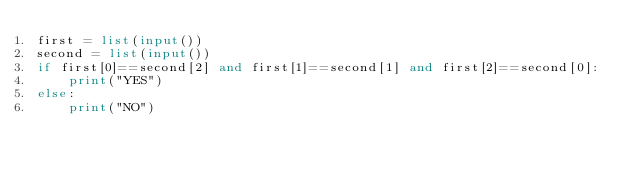Convert code to text. <code><loc_0><loc_0><loc_500><loc_500><_Python_>first = list(input())
second = list(input())
if first[0]==second[2] and first[1]==second[1] and first[2]==second[0]:
    print("YES")
else:
    print("NO")</code> 